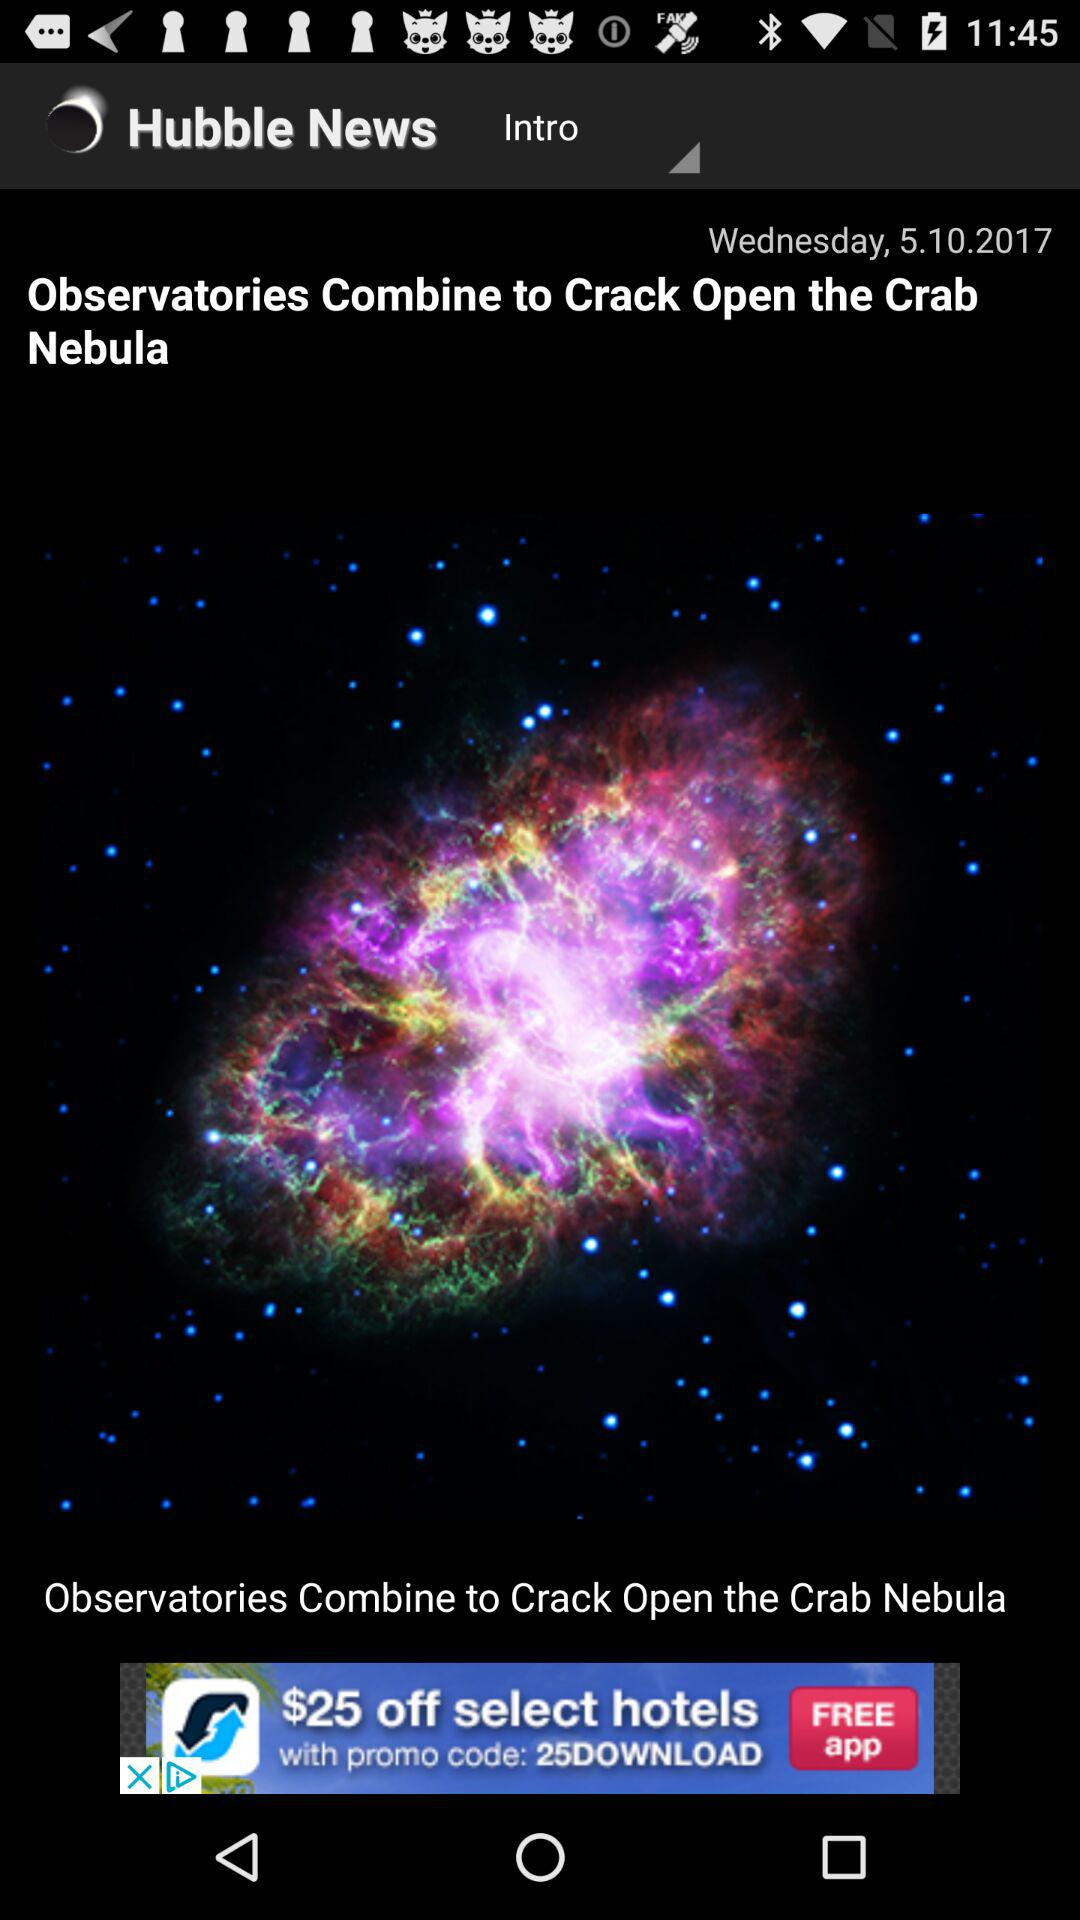Which day falls on 5.10.2017? The day is Wednesday. 